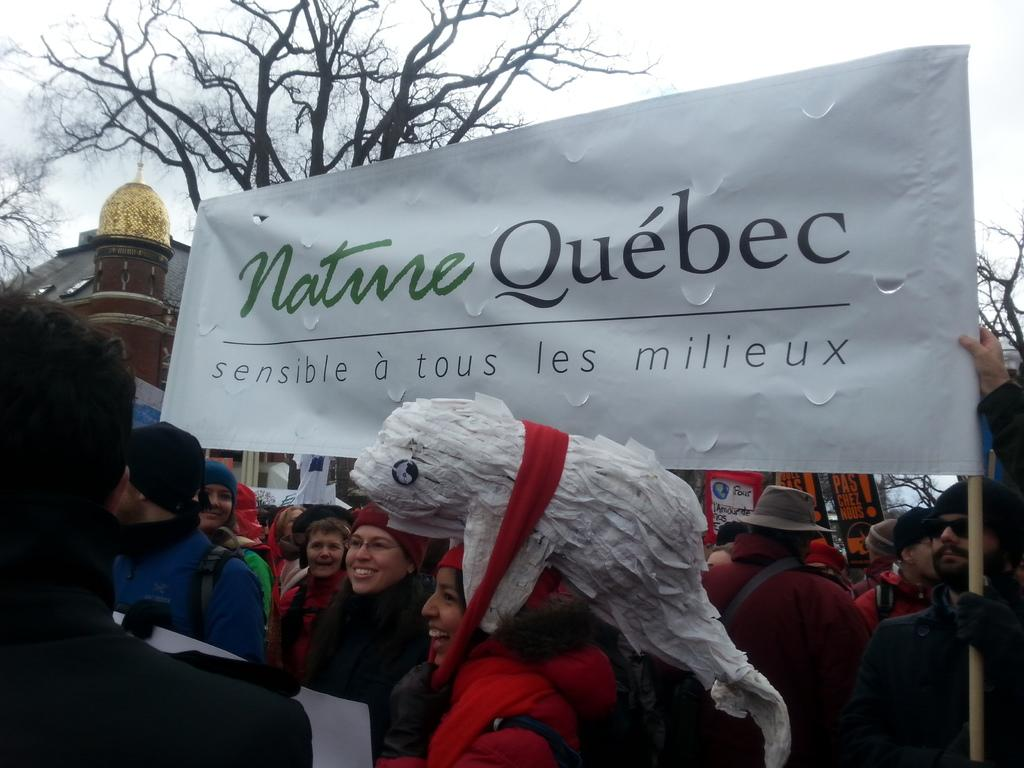Who or what can be seen in the image? There are people in the image. What type of natural elements are present in the image? There are trees in the image. What type of man-made structures can be seen in the image? There are houses in the image. What type of signage is present in the image? There are boards with text and a banner with text in the image. What is visible in the background of the image? The sky is visible in the image. What color is the object that stands out in the image? There is a white colored object in the image. What type of smell can be detected in the image? There is no information about smells in the image, so it cannot be determined from the image. Is the image taken near a coast? There is no information about the location or proximity to a coast in the image, so it cannot be determined from the image. 